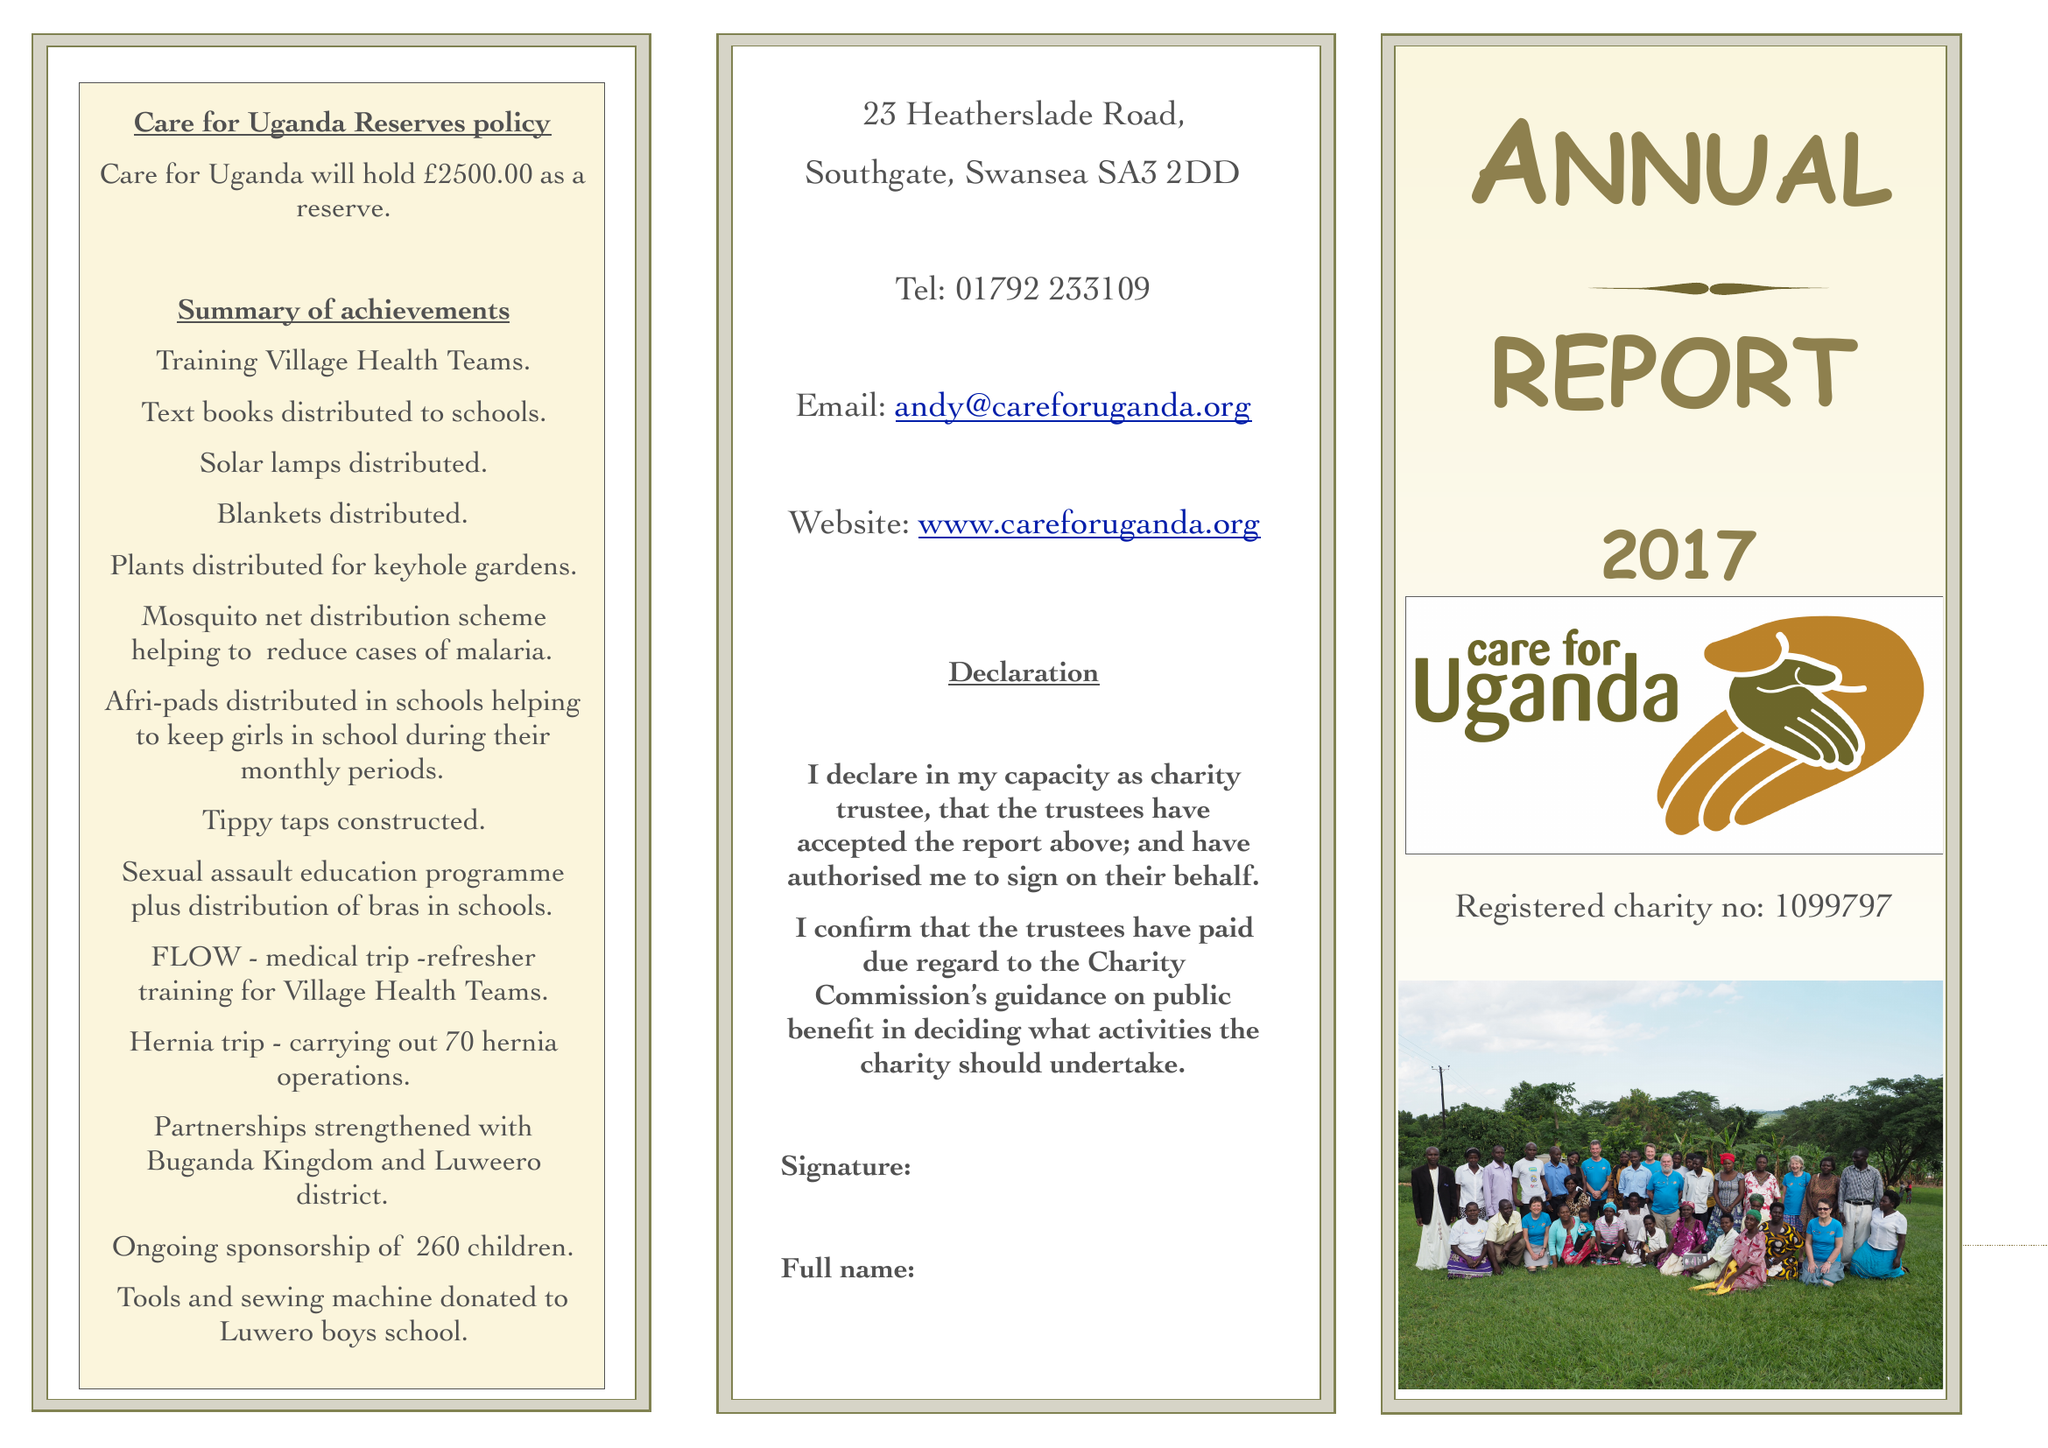What is the value for the spending_annually_in_british_pounds?
Answer the question using a single word or phrase. 135011.00 